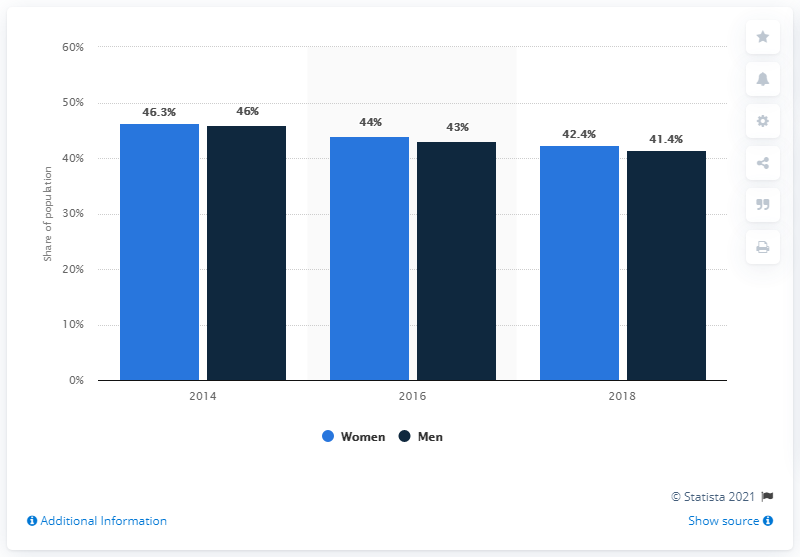Draw attention to some important aspects in this diagram. In 2018, the poverty rate among women in Mexico was 42.4%. In 2018, the poverty rate among males was 41.4%. 